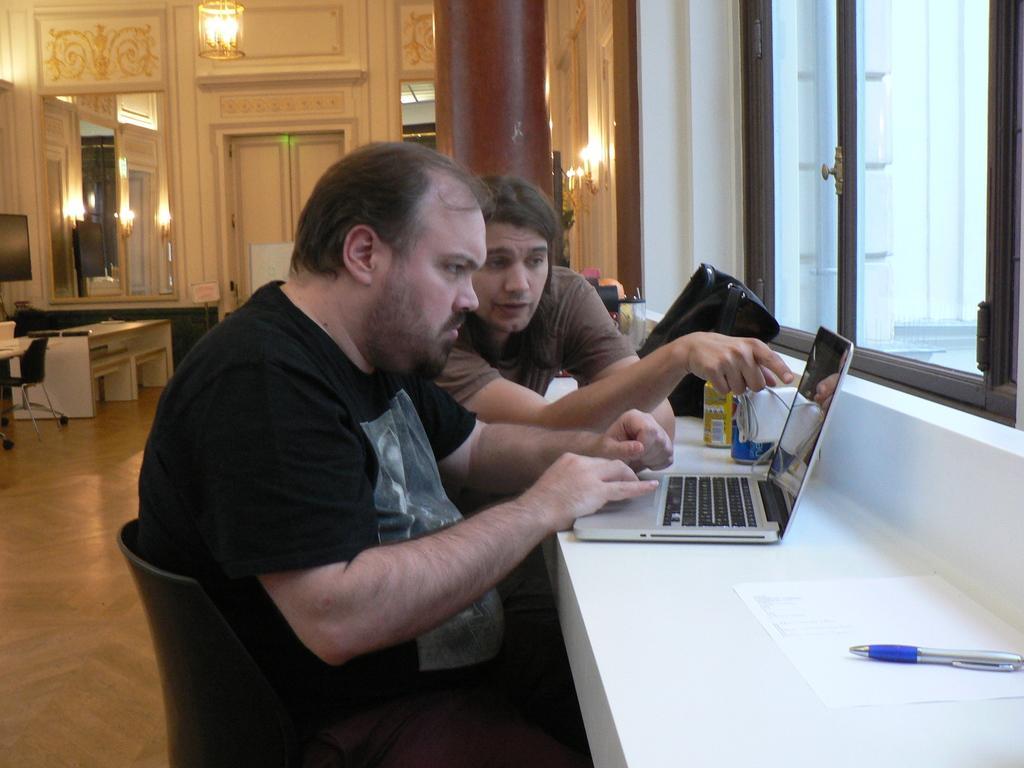Please provide a concise description of this image. There are two man sitting on a chair operating laptop and beside that there is a paper and a pen on it. Behind the man there is a TV and table and glass wall. On the ceiling there is a chandler hanging and light in it. 